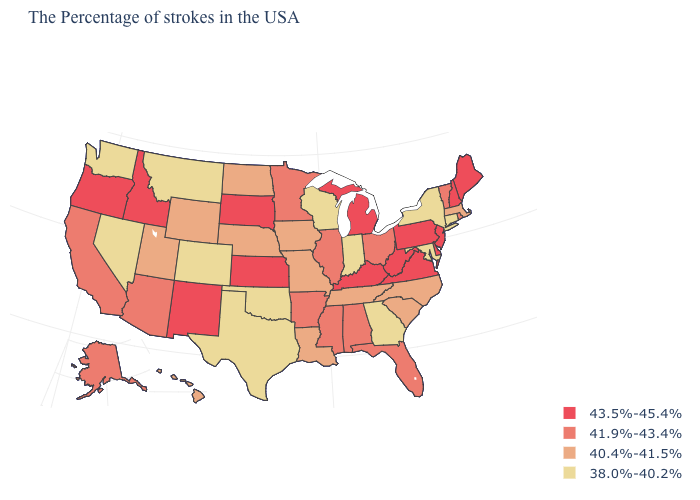Name the states that have a value in the range 43.5%-45.4%?
Keep it brief. Maine, New Hampshire, New Jersey, Delaware, Pennsylvania, Virginia, West Virginia, Michigan, Kentucky, Kansas, South Dakota, New Mexico, Idaho, Oregon. Which states have the lowest value in the USA?
Answer briefly. Connecticut, New York, Maryland, Georgia, Indiana, Wisconsin, Oklahoma, Texas, Colorado, Montana, Nevada, Washington. Name the states that have a value in the range 38.0%-40.2%?
Answer briefly. Connecticut, New York, Maryland, Georgia, Indiana, Wisconsin, Oklahoma, Texas, Colorado, Montana, Nevada, Washington. What is the value of Kansas?
Answer briefly. 43.5%-45.4%. Among the states that border Indiana , does Kentucky have the highest value?
Write a very short answer. Yes. Name the states that have a value in the range 41.9%-43.4%?
Short answer required. Rhode Island, Vermont, Ohio, Florida, Alabama, Illinois, Mississippi, Arkansas, Minnesota, Arizona, California, Alaska. Does Maine have the highest value in the Northeast?
Quick response, please. Yes. Which states have the highest value in the USA?
Short answer required. Maine, New Hampshire, New Jersey, Delaware, Pennsylvania, Virginia, West Virginia, Michigan, Kentucky, Kansas, South Dakota, New Mexico, Idaho, Oregon. Name the states that have a value in the range 41.9%-43.4%?
Answer briefly. Rhode Island, Vermont, Ohio, Florida, Alabama, Illinois, Mississippi, Arkansas, Minnesota, Arizona, California, Alaska. What is the lowest value in the USA?
Keep it brief. 38.0%-40.2%. Does Georgia have the lowest value in the USA?
Concise answer only. Yes. How many symbols are there in the legend?
Be succinct. 4. Which states have the lowest value in the USA?
Answer briefly. Connecticut, New York, Maryland, Georgia, Indiana, Wisconsin, Oklahoma, Texas, Colorado, Montana, Nevada, Washington. What is the value of Montana?
Give a very brief answer. 38.0%-40.2%. Name the states that have a value in the range 41.9%-43.4%?
Answer briefly. Rhode Island, Vermont, Ohio, Florida, Alabama, Illinois, Mississippi, Arkansas, Minnesota, Arizona, California, Alaska. 